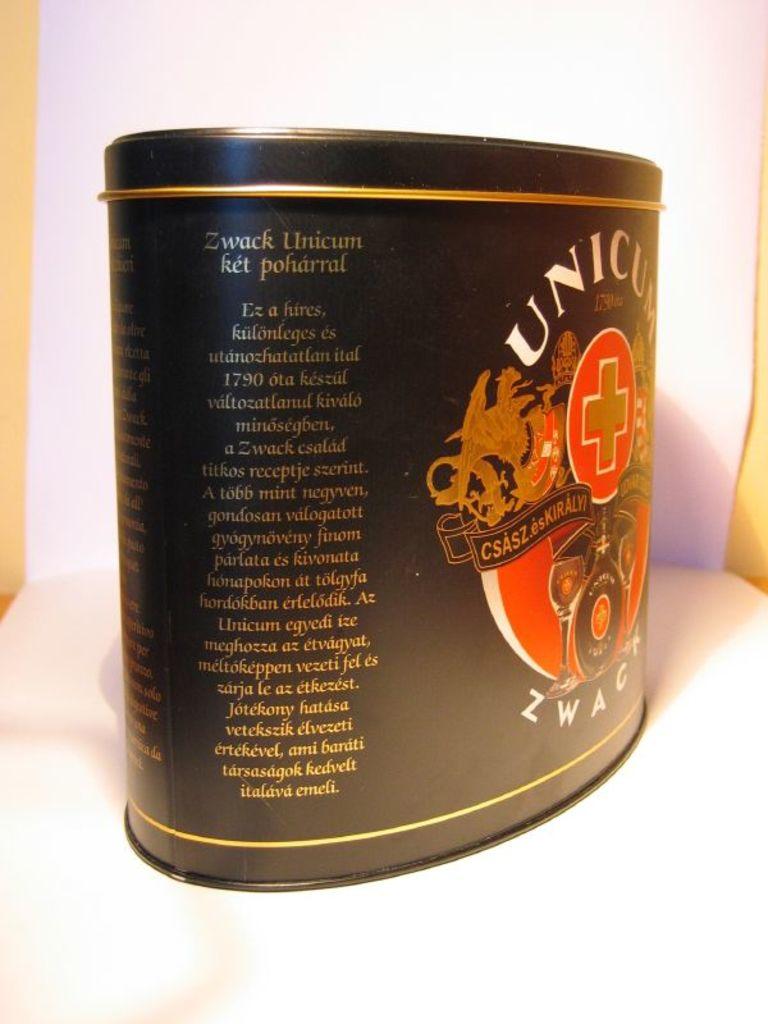What's the first line of gold text on the can?
Give a very brief answer. Zwack unicum. 